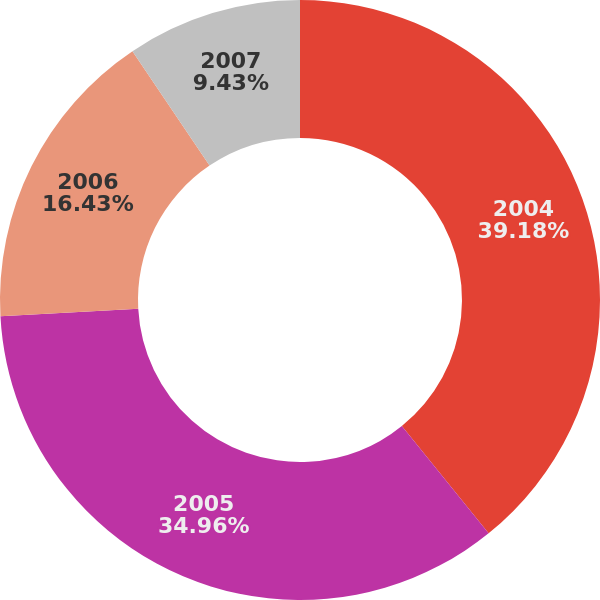Convert chart. <chart><loc_0><loc_0><loc_500><loc_500><pie_chart><fcel>2004<fcel>2005<fcel>2006<fcel>2007<nl><fcel>39.18%<fcel>34.96%<fcel>16.43%<fcel>9.43%<nl></chart> 